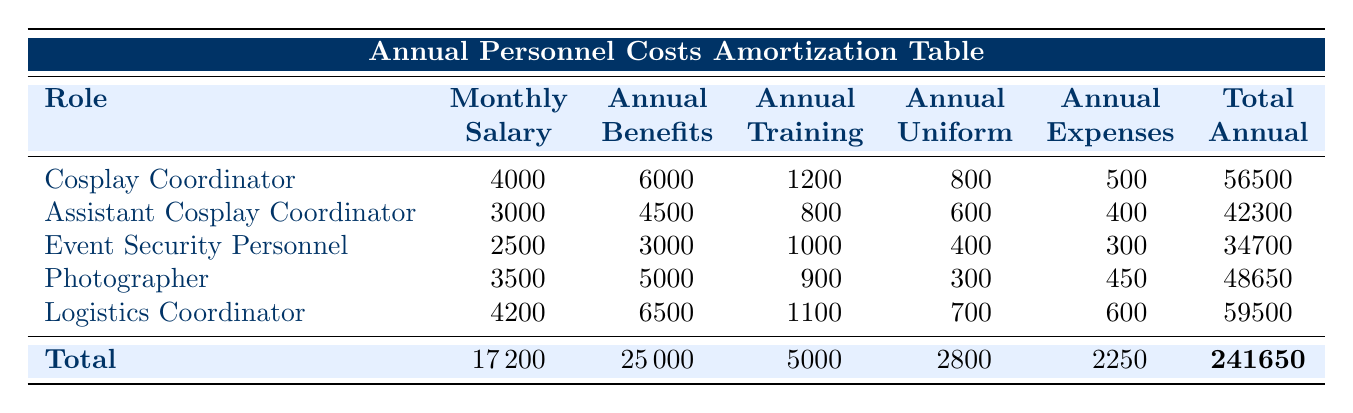What is the total annual personnel cost for a Cosplay Coordinator? The table shows that the total annual cost for a Cosplay Coordinator is presented in the last column for that role, which is 56500.
Answer: 56500 How much does an Assistant Cosplay Coordinator earn monthly? The monthly salary for the Assistant Cosplay Coordinator is specified in the second column of the table, listed as 3000.
Answer: 3000 Is the annual training cost higher for the Photographer than for the Event Security Personnel? Looking at the annual training costs listed for both roles, the Photographer's cost is 900, while the Event Security Personnel's cost is 1000. Therefore, the Photographer's training cost is lower, making the statement false.
Answer: No What is the combined total annual expense for both the Cosplay Coordinator and Logistics Coordinator? To find the combined total, we sum the total annual costs for both roles: Cosplay Coordinator (56500) + Logistics Coordinator (59500) = 116000.
Answer: 116000 Which role has the highest total annual cost? By examining the total annual costs in the last column of the table, the Logistics Coordinator shows the highest figure at 59500. Therefore, the role with the highest total cost is the Logistics Coordinator.
Answer: Logistics Coordinator What is the average annual expense for the roles listed in the table? To find the average, we add the total annual costs of all roles (241650) and divide by the number of roles (5). The total is 241650 / 5 = 48330.
Answer: 48330 Does the Event Security Personnel incur more costs in uniforms than the Photographer? The table shows uniform costs for Event Security Personnel (400) and for the Photographer (300). Since 400 is greater than 300, the Event Security Personnel do incur higher uniform costs.
Answer: Yes What is the total amount spent on benefits for all personnel combined? The total benefits can be found by adding the annual benefits for each role (6000 + 4500 + 3000 + 5000 + 6500 = 25000). Therefore, the total spent on benefits is 25000.
Answer: 25000 Which role has the lowest total annual cost? From the total annual costs presented, the Event Security Personnel has the lowest total at 34700.
Answer: Event Security Personnel 